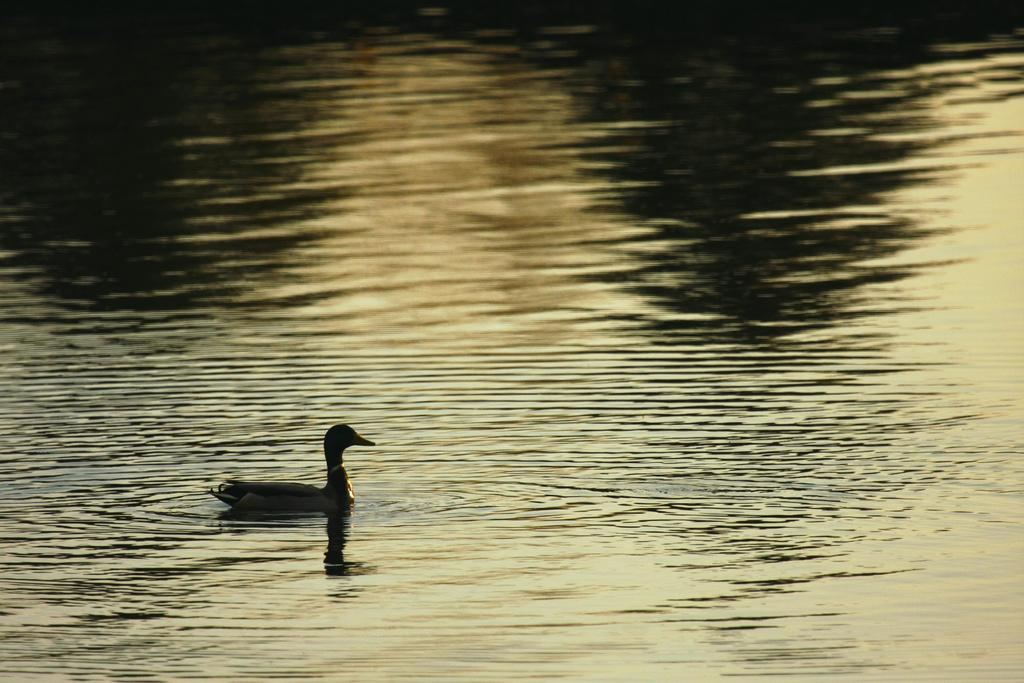What type of animal is in the image? There is a bird in the image. Where is the bird located in the image? The bird is on the water and on the left side of the image. What type of sticks can be seen in the image? There are no sticks present in the image. What feeling does the bird seem to be experiencing in the image? The image does not convey any specific feelings or emotions of the bird, so it cannot be determined from the image. 